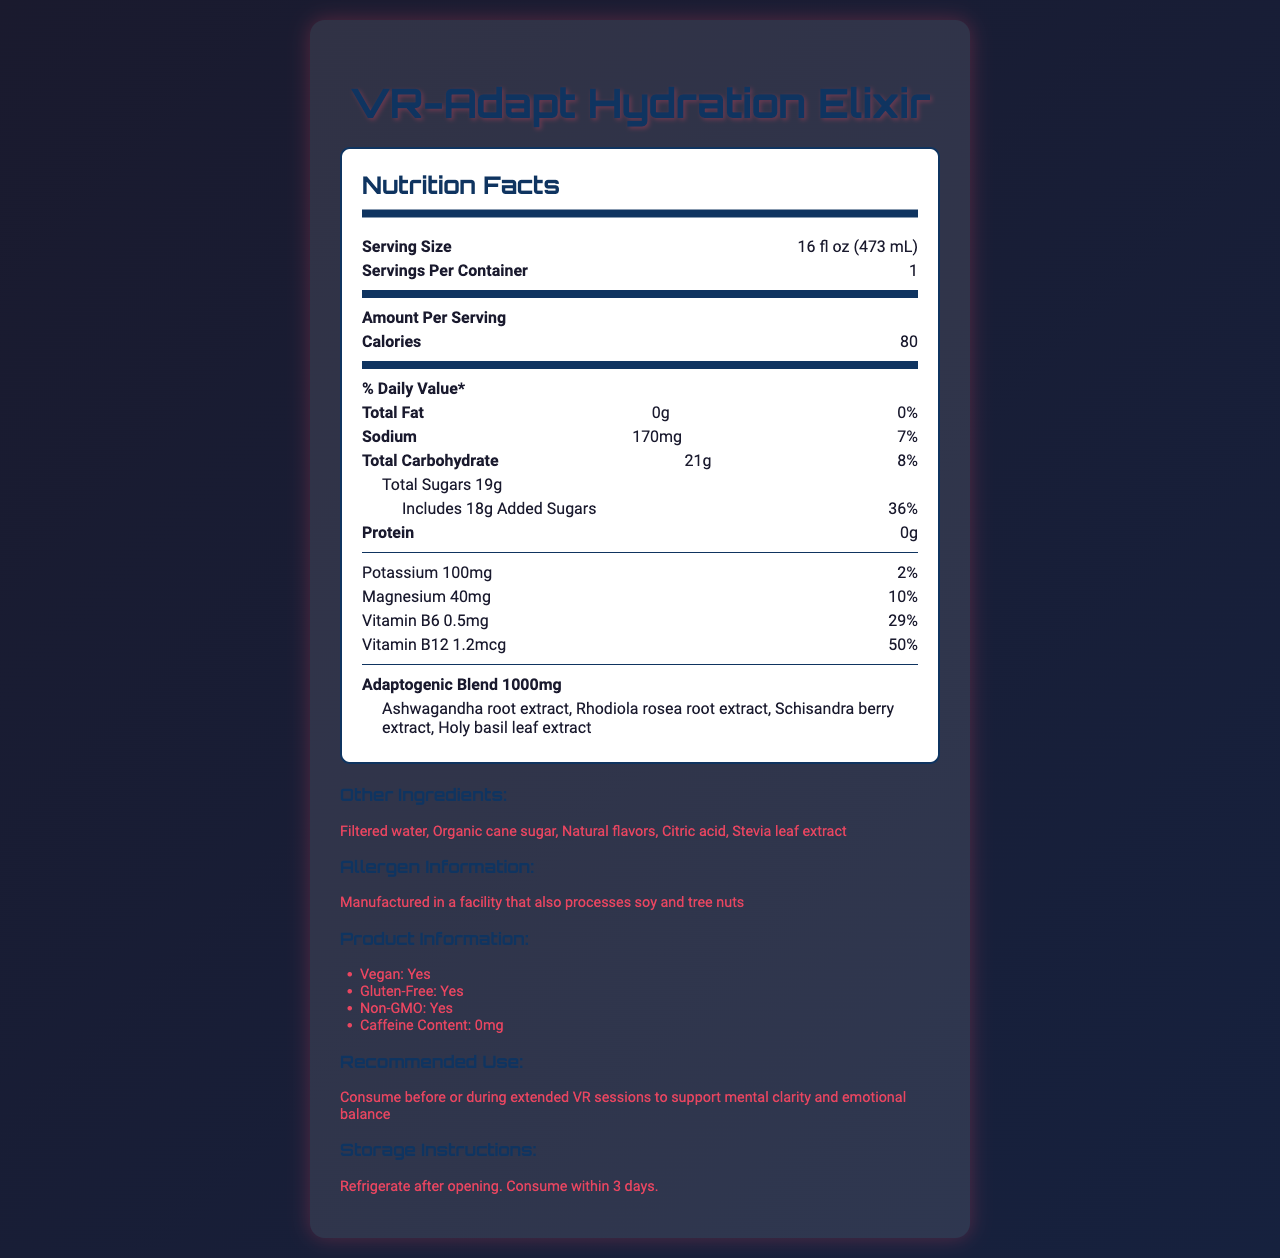What is the serving size of the VR-Adapt Hydration Elixir? The serving size is mentioned at the beginning of the nutrition facts in the serving size section.
Answer: 16 fl oz (473 mL) How many calories are in one serving of the VR-Adapt Hydration Elixir? The number of calories per serving is explicitly listed under the amount per serving section.
Answer: 80 List the ingredients in the adaptogenic blend. The ingredients of the adaptogenic blend are mentioned under the Adaptogenic Blend section.
Answer: Ashwagandha root extract, Rhodiola rosea root extract, Schisandra berry extract, Holy basil leaf extract What is the amount of sodium in one serving? The sodium content is specified under the sodium section with its corresponding daily value percentage.
Answer: 170mg Is this beverage gluten-free? The document states in the product information section that the beverage is gluten-free.
Answer: Yes Which of the following is not an ingredient in the VR-Adapt Hydration Elixir? A. Filtered water B. Citric acid C. Artificial sweeteners D. Organic cane sugar The listed ingredients include filtered water, citric acid, and organic cane sugar but do not include artificial sweeteners.
Answer: C. Artificial sweeteners What percentage of the daily value for Vitamin B12 does one serving provide? A. 29% B. 2% C. 10% D. 50% The document states that Vitamin B12 amount is 1.2mcg which provides 50% of the daily value.
Answer: D. 50% Can you determine the exact number of VR sessions this beverage is best suited for? The document provides a recommendation to consume before or during extended VR sessions but does not specify an exact number.
Answer: Cannot be determined Is the VR-Adapt Hydration Elixir suitable for vegans? The product information section indicates that the beverage is vegan.
Answer: Yes Summarize the main nutritional benefits of the VR-Adapt Hydration Elixir. The beverage is highlighted as beneficial for mental clarity and emotional balance during VR sessions due to its adaptogenic blend and essential nutrients, while being suitable for various dietary restrictions.
Answer: The VR-Adapt Hydration Elixir is designed to support mental resilience during intense VR experiences. It contains adaptogenic herbs and provides hydration with added nutrients like vitamins B6 and B12, potassium, and magnesium. It is also gluten-free, vegan, and non-GMO. 